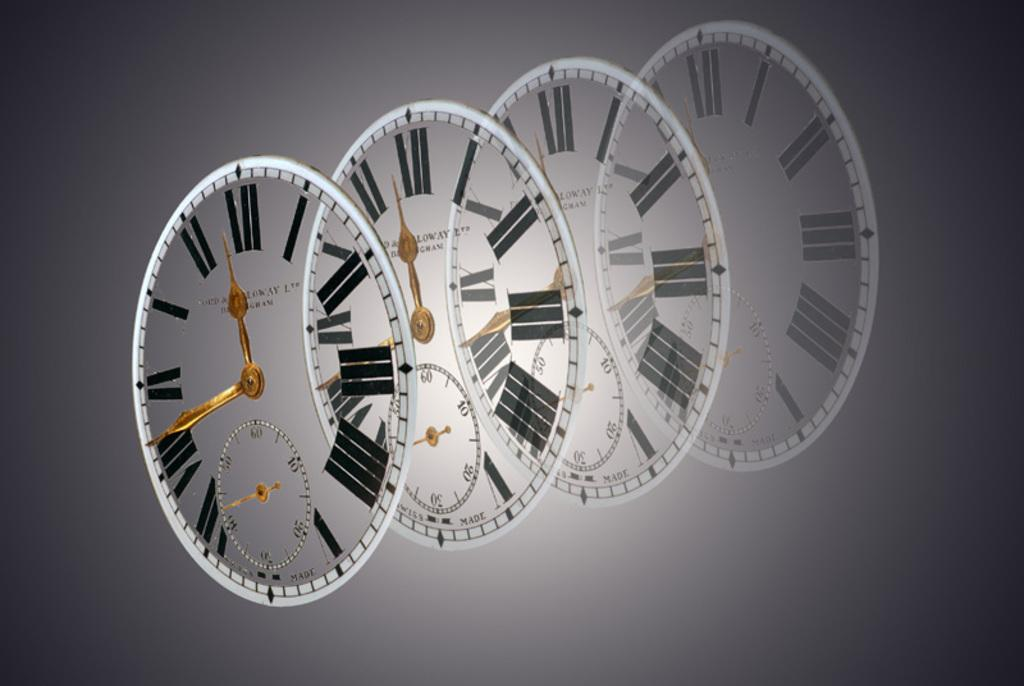<image>
Summarize the visual content of the image. 4 faces of a clock made from a "ltd" company is shown gradually fading into the background. 